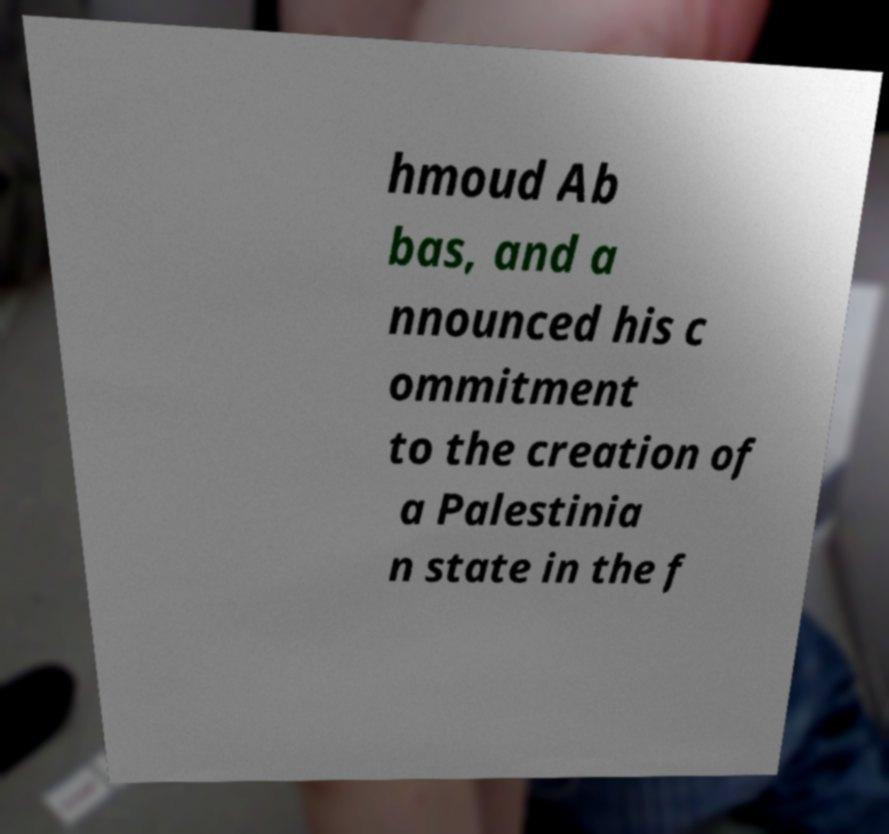Can you read and provide the text displayed in the image?This photo seems to have some interesting text. Can you extract and type it out for me? hmoud Ab bas, and a nnounced his c ommitment to the creation of a Palestinia n state in the f 